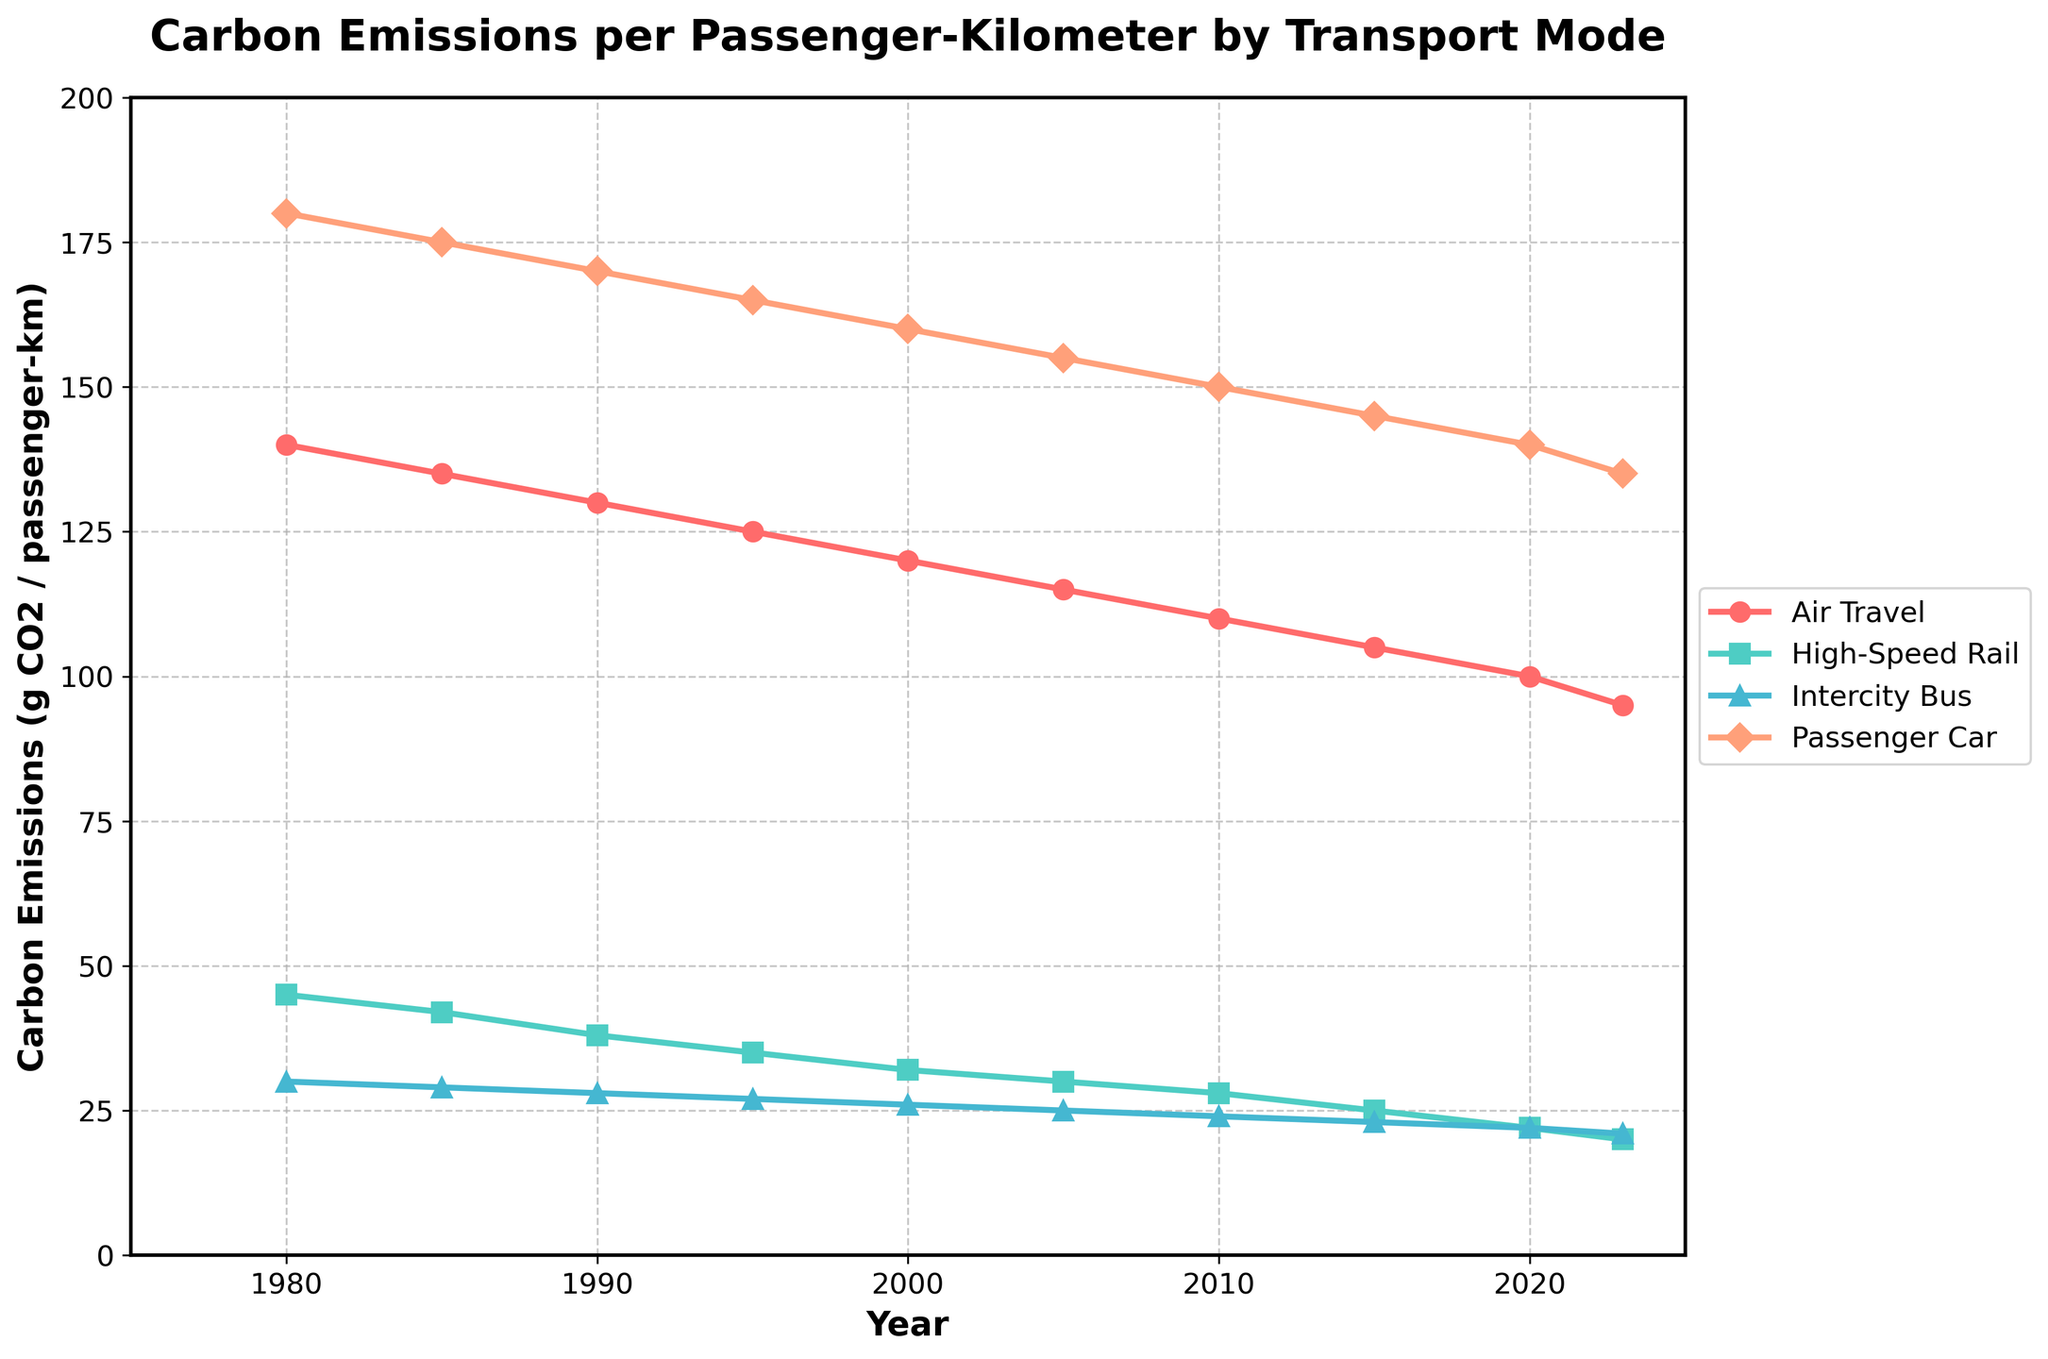What mode of transport had the highest carbon emissions per passenger-kilometer in 1980? Looking at the data for 1980, air travel has the highest emissions at 140 g CO2 per passenger-kilometer.
Answer: Air travel Between 2000 and 2023, which mode of transport showed the largest decrease in carbon emissions per passenger-kilometer? The reductions for each mode from 2000 to 2023 are: Air Travel (120-95=25), High-Speed Rail (32-20=12), Intercity Bus (26-21=5), and Passenger Car (160-135=25). Both Air Travel and Passenger Car show a reduction of 25.
Answer: Air Travel and Passenger Car What is the average carbon emission reduction per decade for air travel between 1980 and 2023? Compute the differences per decade: [(140-135), (135-130), (130-125), (125-120), (120-115), (115-110), (110-105), (105-100), (100-95)] = [5, 5, 5, 5, 5, 5, 5, 5, 5]. Taking average, (5*9)/9 = 5 g CO2 per decade.
Answer: 5 g CO2 per decade In which year did passenger cars first emit less than 150 g CO2 per passenger-kilometer? Tracking the carbon emissions for passenger cars, the value first drops below 150 in 2005 with an emission of 155 g CO2.
Answer: 2005 If trends continue, in what approximate year might we expect high-speed rail emissions to drop below 15 g CO2 per passenger-kilometer? From 2015 to 2023, high-speed rail emissions reduced from 25 to 20 g CO2, a reduction of 5 g over 8 years, or 0.625 g per year. Extending this trend, 20 g minus 0.625g/year will take ~8 years to drop below 15g, so approximately around 2031.
Answer: 2031 